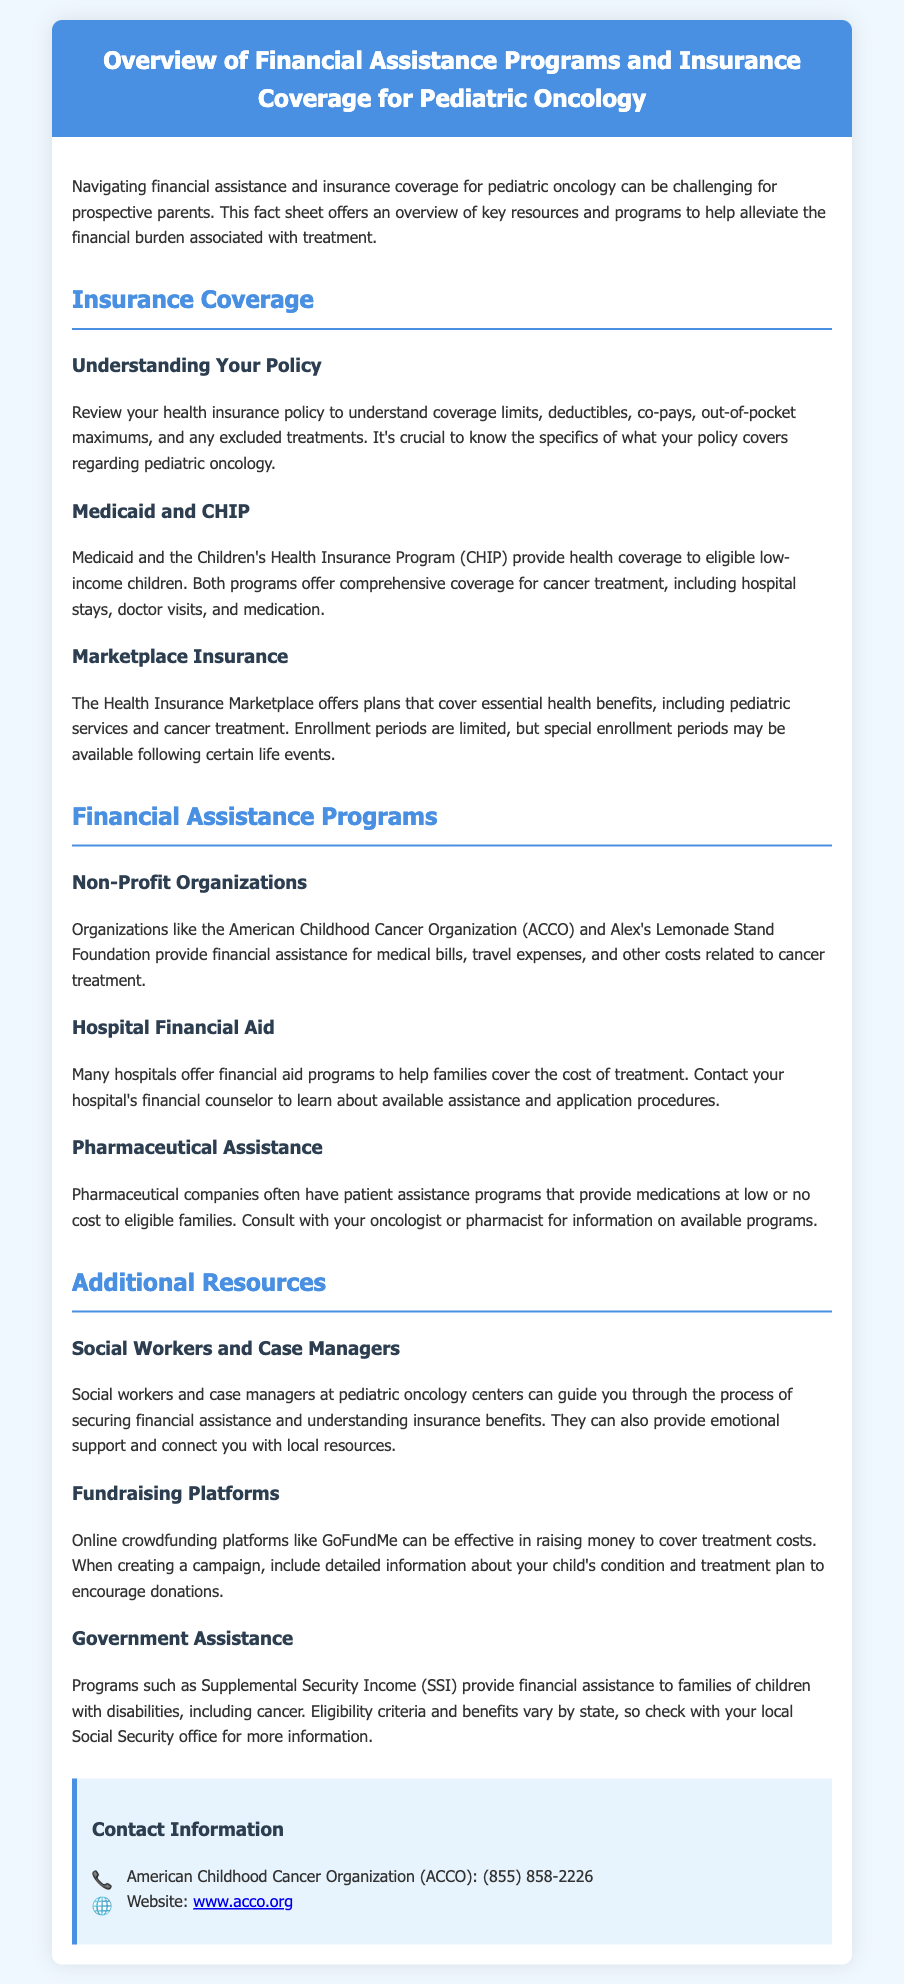What are the main assistance programs listed for pediatric oncology? The document mentions Non-Profit Organizations, Hospital Financial Aid, and Pharmaceutical Assistance as main financial assistance programs.
Answer: Non-Profit Organizations, Hospital Financial Aid, Pharmaceutical Assistance What does CHIP stand for? CHIP refers to the Children's Health Insurance Program, which is mentioned as providing health coverage to eligible low-income children.
Answer: Children's Health Insurance Program What is one organization that provides financial assistance for pediatric cancer? The document specifies the American Childhood Cancer Organization (ACCO) as one organization providing financial assistance.
Answer: American Childhood Cancer Organization (ACCO) Who can help navigate financial assistance at pediatric oncology centers? The document states that social workers and case managers can guide families in securing financial assistance.
Answer: Social workers and case managers What is a special enrollment period? The document indicates that special enrollment periods may be available following certain life events for Marketplace Insurance plans.
Answer: Following certain life events What should you review to understand insurance coverage for pediatric oncology? The document suggests reviewing your health insurance policy to understand coverage limits, deductibles, co-pays, out-of-pocket maximums, and excluded treatments.
Answer: Your health insurance policy What type of assistance does Supplemental Security Income (SSI) provide? The document mentions that SSI provides financial assistance to families of children with disabilities, including cancer.
Answer: Financial assistance What is a recommended online platform for fundraising for treatment costs? According to the document, crowdfunding platforms like GoFundMe are effective for raising money to cover treatment costs.
Answer: GoFundMe 